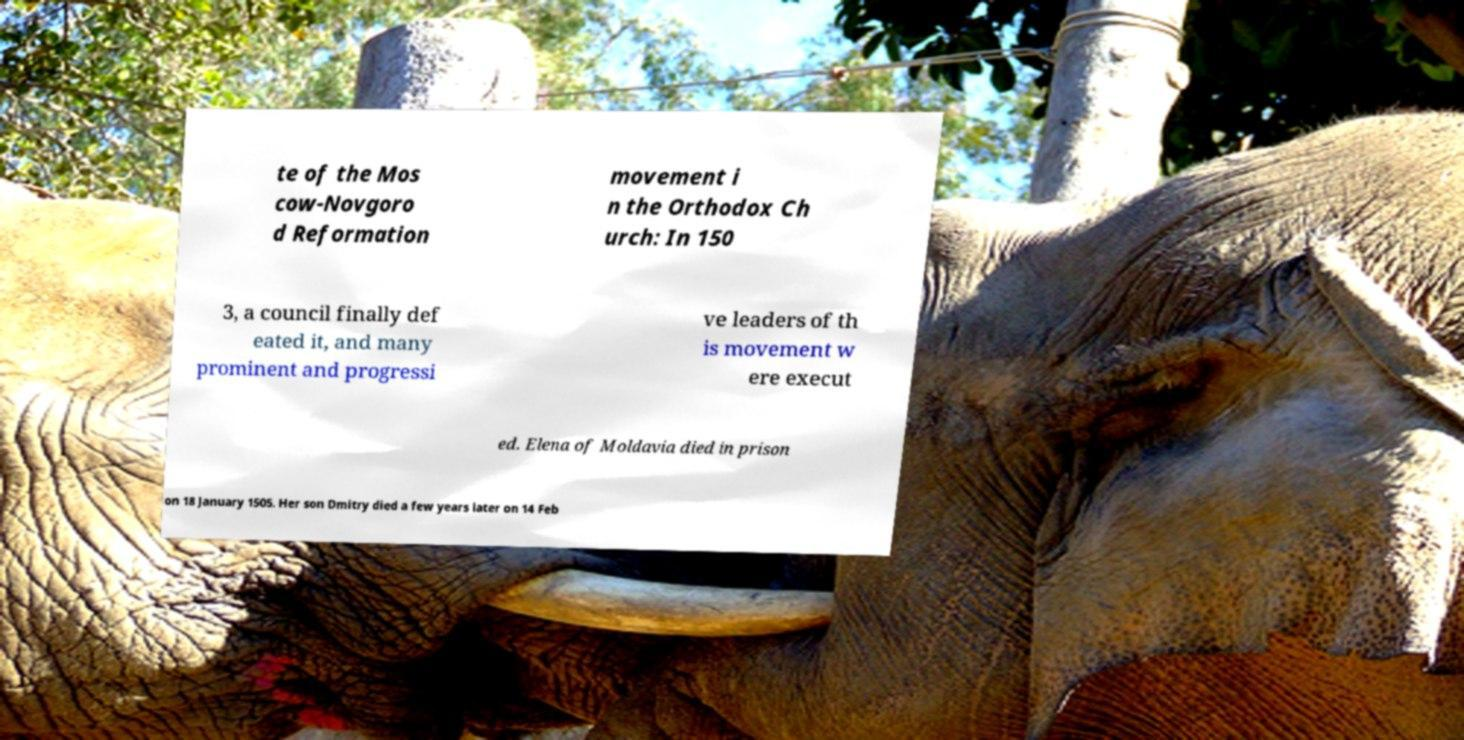There's text embedded in this image that I need extracted. Can you transcribe it verbatim? te of the Mos cow-Novgoro d Reformation movement i n the Orthodox Ch urch: In 150 3, a council finally def eated it, and many prominent and progressi ve leaders of th is movement w ere execut ed. Elena of Moldavia died in prison on 18 January 1505. Her son Dmitry died a few years later on 14 Feb 